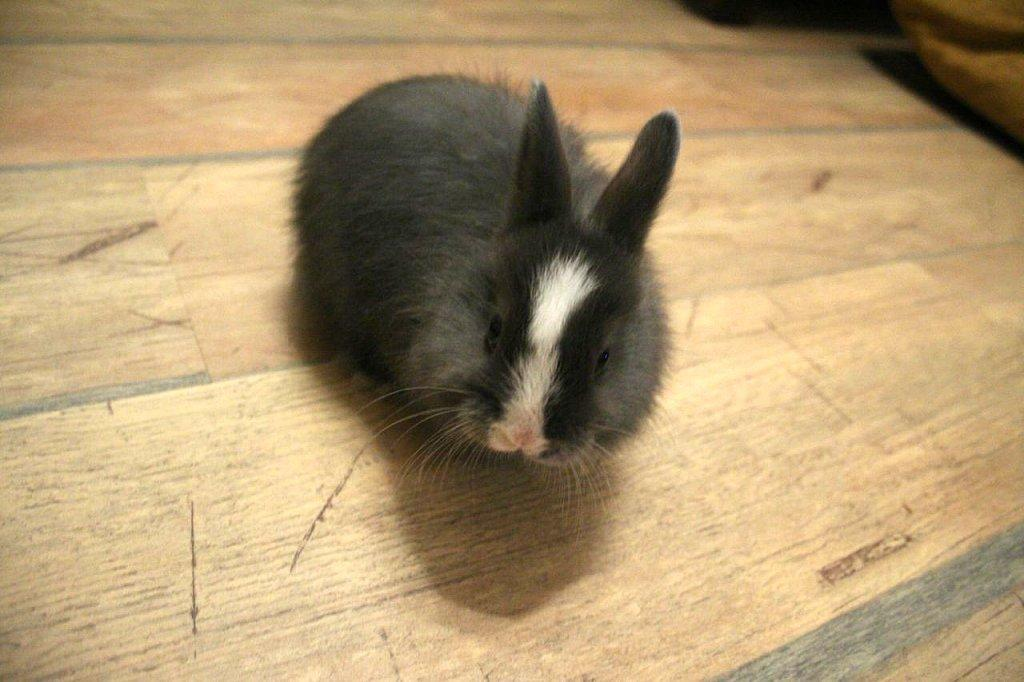What type of animal is in the image? There is an animal in the image, but its specific type cannot be determined from the provided facts. What color is the animal in the image? The animal is in black and white. What surface is the animal on? The animal is on a wooden surface. What can be seen in the background of the image? There is an object in the background of the image. How many turkeys are folded in the image? There are no turkeys present in the image, and the concept of folding does not apply to the animal shown. 